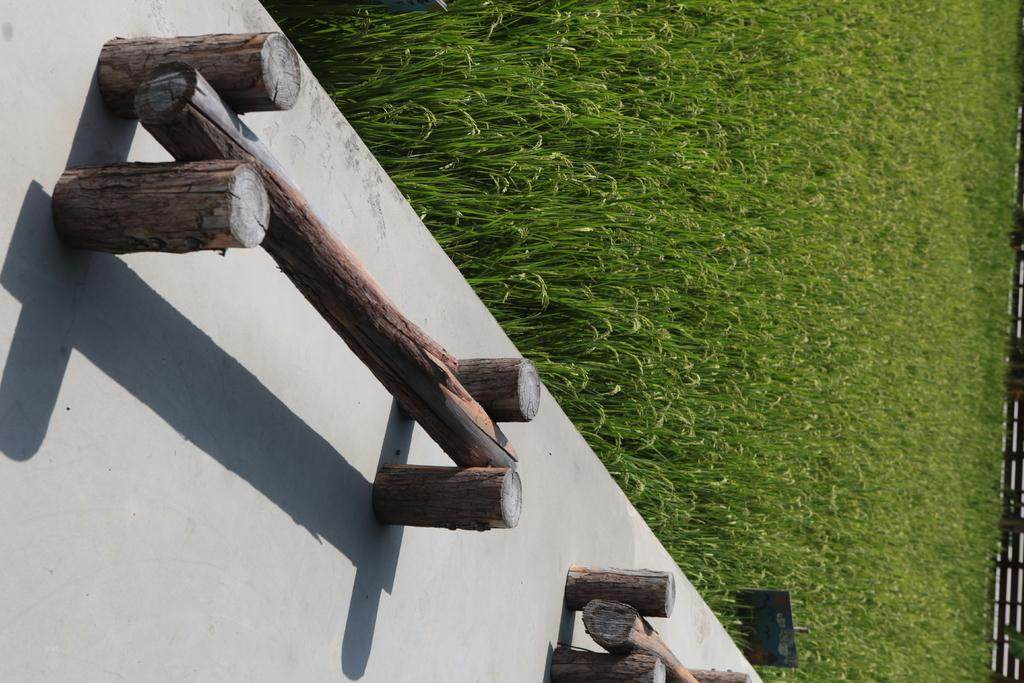What type of objects can be seen in the image that resemble benches? There are wooden objects in the image that resemble benches. What type of vegetation is visible in the image? There is grass visible in the image. What type of barrier can be seen in the image? There is a fence in the image. How many roses are growing on the wooden benches in the image? There are no roses visible in the image; the wooden objects resemble benches, and there is grass and a fence present. 